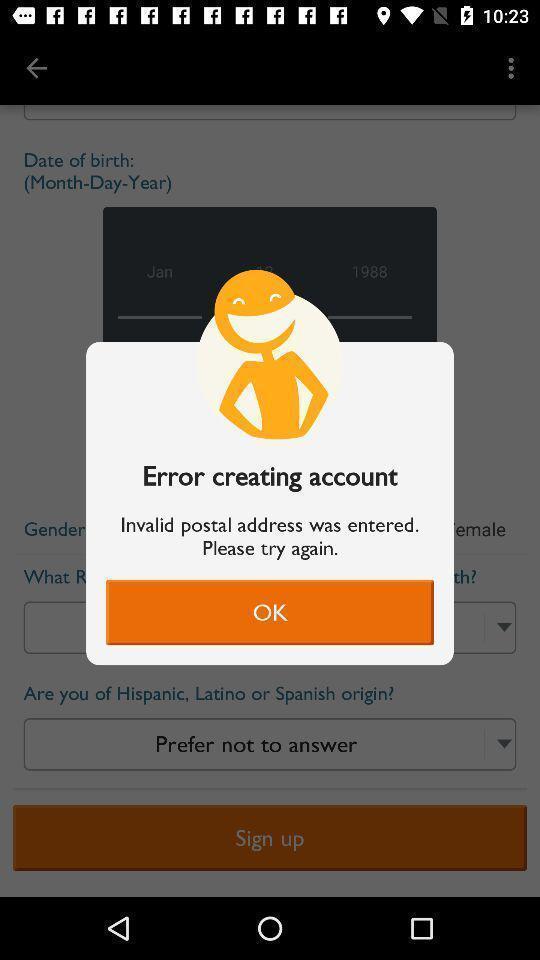Give me a narrative description of this picture. Popup displaying error information about account creation. 